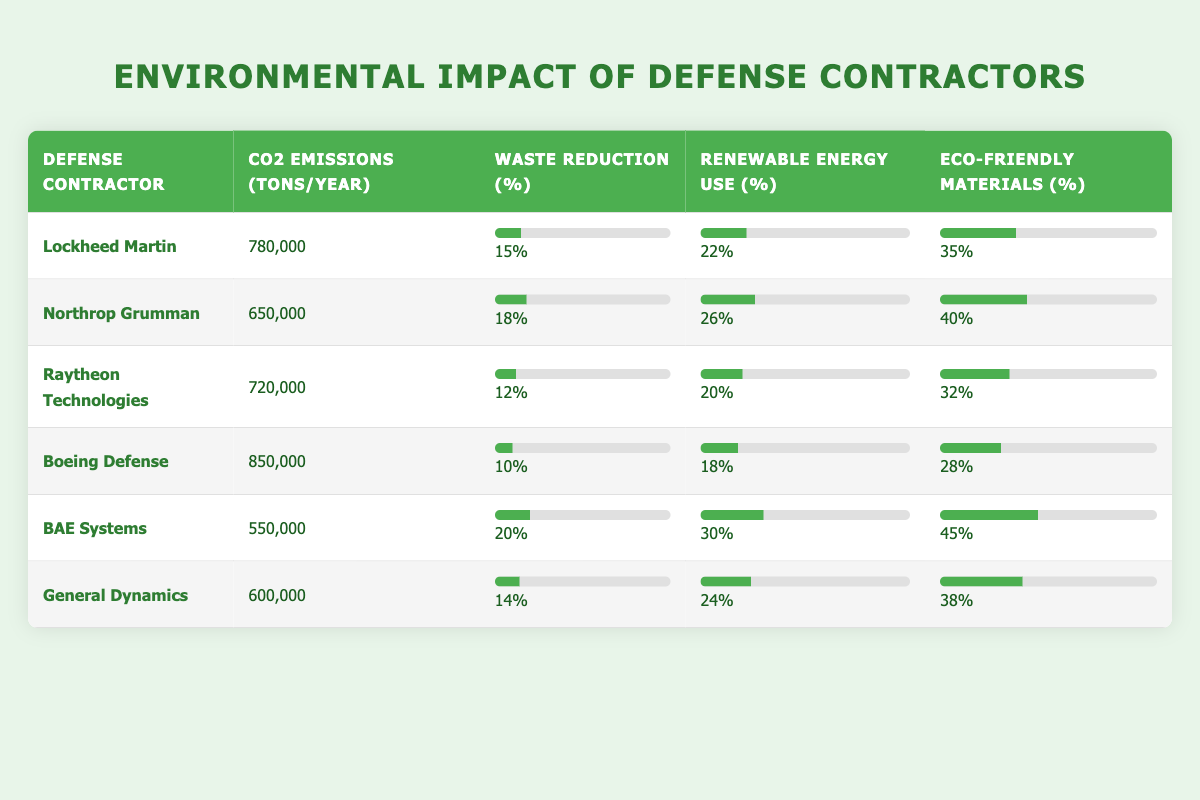What is the CO2 emissions for BAE Systems? The value for BAE Systems in the "CO2 Emissions (tons/year)" column is 550,000.
Answer: 550,000 Which defense contractor has the highest waste reduction percentage? Looking at the "Waste Reduction (%)" column, BAE Systems has the highest waste reduction at 20%.
Answer: BAE Systems What is the average renewable energy use percentage for all contractors? To find the average, sum the renewable energy percentages: (22 + 26 + 20 + 18 + 30 + 24) = 140. There are 6 contractors, so the average is 140/6 = 23.33%.
Answer: 23.33% Is Northrop Grumman using more eco-friendly materials than Raytheon Technologies? Checking the "% Eco-friendly Materials," Northrop Grumman has 40%, while Raytheon Technologies has 32%. Therefore, Northrop Grumman uses more eco-friendly materials.
Answer: Yes Which contractor has the lowest CO2 emissions, and what is that amount? The CO2 emissions are lowest for BAE Systems, with an amount of 550,000 tons/year.
Answer: 550,000 What is the difference in the eco-friendly materials percentage between Lockheed Martin and Northrop Grumman? Lockheed Martin has 35% eco-friendly materials, and Northrop Grumman has 40%. The difference is 40% - 35% = 5%.
Answer: 5% Which contractors have a renewable energy use percentage greater than the overall average? The average for renewable energy use is 23.33%. The contractors above this average are Northrop Grumman (26%), BAE Systems (30%), and General Dynamics (24%).
Answer: Northrop Grumman, BAE Systems Does Boeing Defense have a higher waste reduction percentage than Raytheon Technologies? Boeing Defense's waste reduction percentage is 10%, while Raytheon Technologies has 12%. Since 10% is less, Boeing does not have a higher percentage.
Answer: No What is the total CO2 emissions of all contractors combined? To find the total, sum the CO2 emissions: 780,000 + 650,000 + 720,000 + 850,000 + 550,000 + 600,000 = 3,250,000 tons/year.
Answer: 3,250,000 